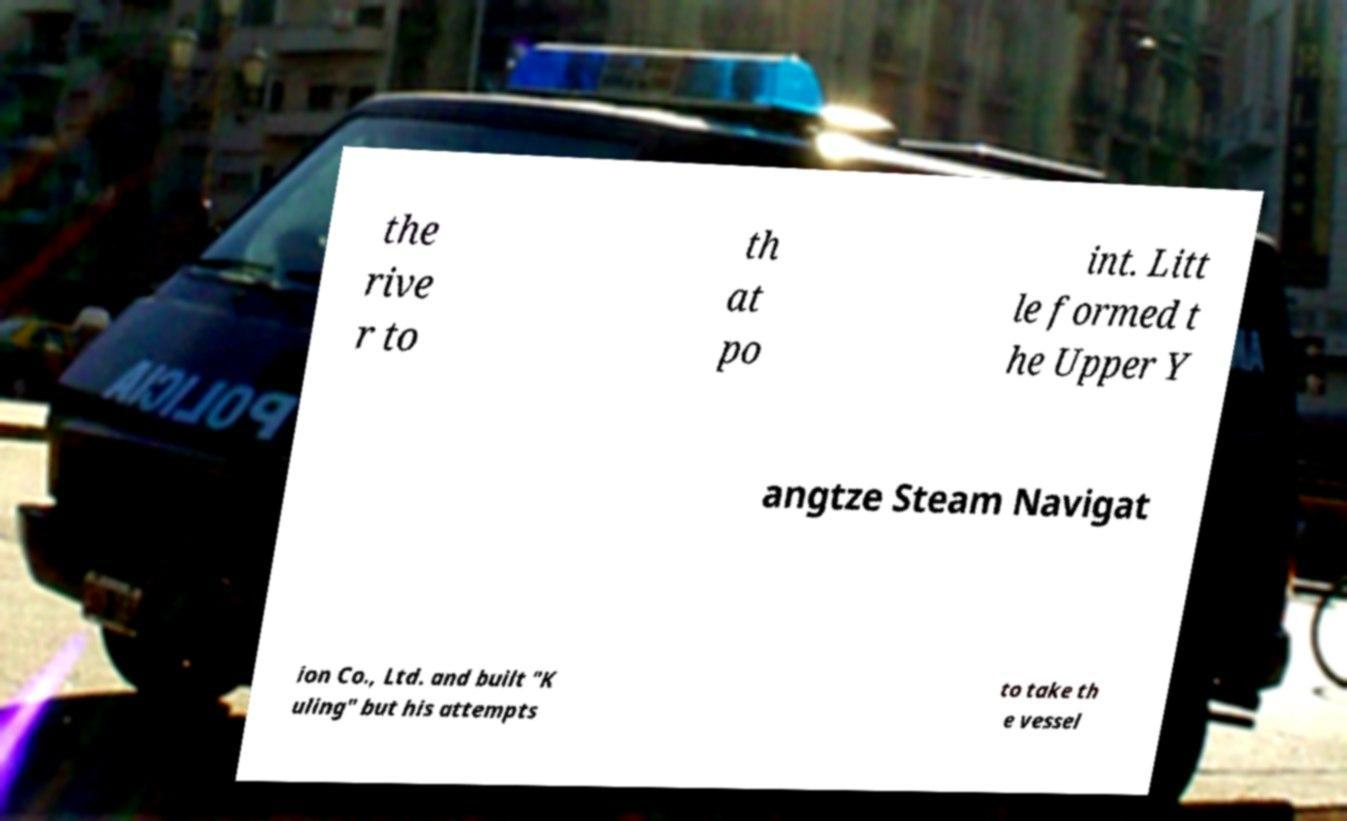Could you extract and type out the text from this image? the rive r to th at po int. Litt le formed t he Upper Y angtze Steam Navigat ion Co., Ltd. and built "K uling" but his attempts to take th e vessel 